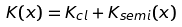<formula> <loc_0><loc_0><loc_500><loc_500>K ( x ) = K _ { c l } + K _ { s e m i } ( x )</formula> 